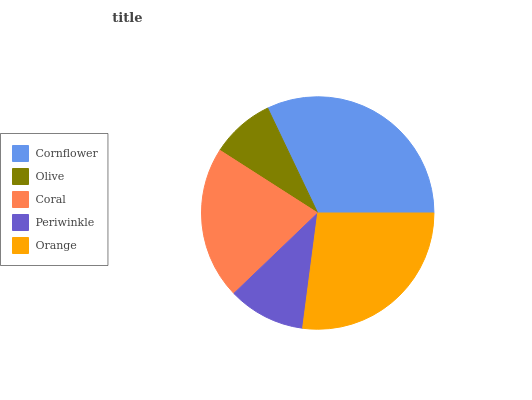Is Olive the minimum?
Answer yes or no. Yes. Is Cornflower the maximum?
Answer yes or no. Yes. Is Coral the minimum?
Answer yes or no. No. Is Coral the maximum?
Answer yes or no. No. Is Coral greater than Olive?
Answer yes or no. Yes. Is Olive less than Coral?
Answer yes or no. Yes. Is Olive greater than Coral?
Answer yes or no. No. Is Coral less than Olive?
Answer yes or no. No. Is Coral the high median?
Answer yes or no. Yes. Is Coral the low median?
Answer yes or no. Yes. Is Cornflower the high median?
Answer yes or no. No. Is Periwinkle the low median?
Answer yes or no. No. 